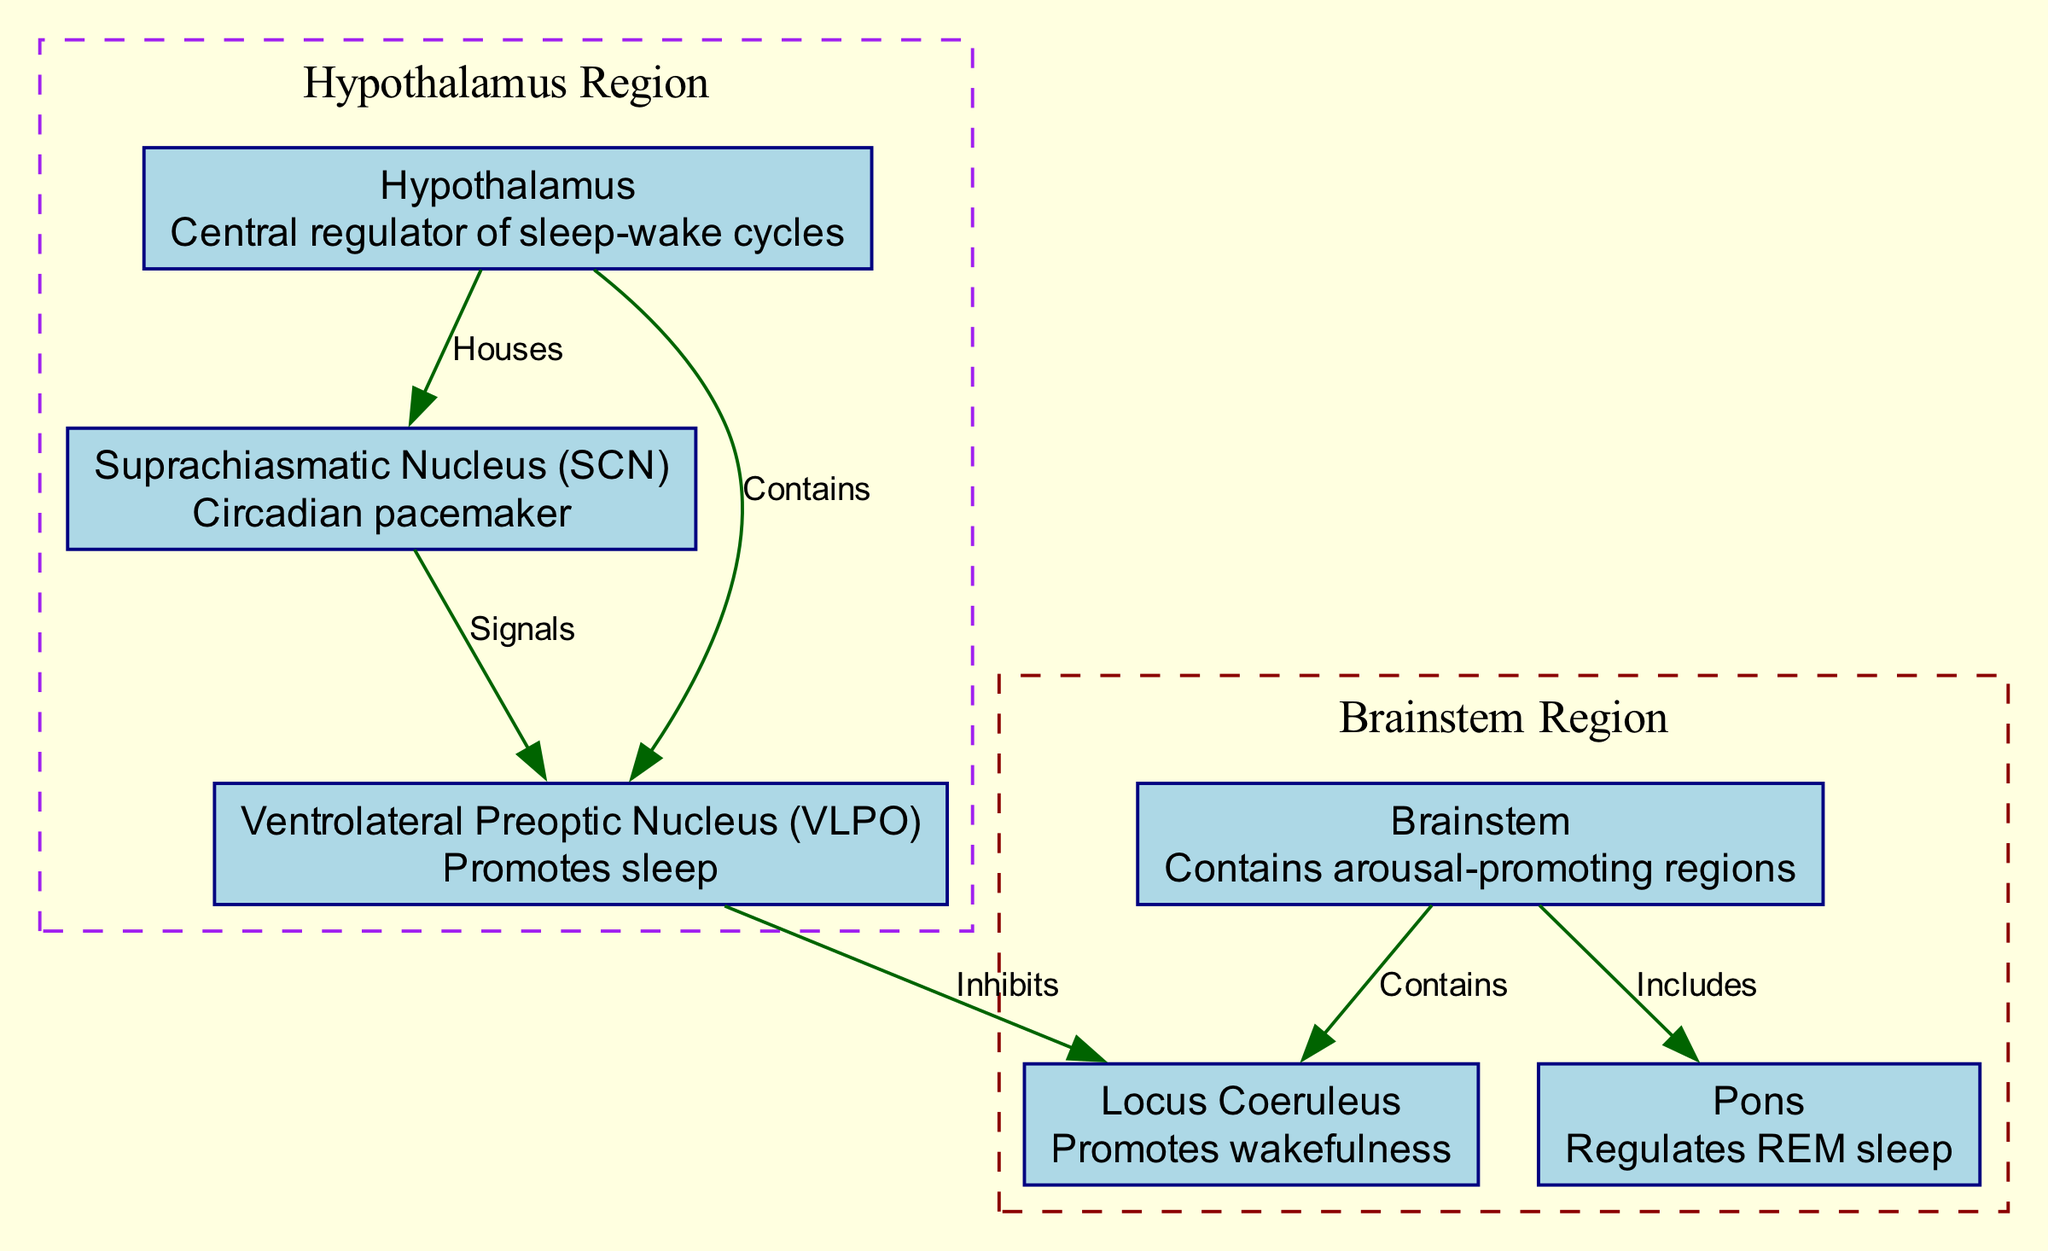What region of the brain is the central regulator of sleep-wake cycles? The diagram indicates that the "Hypothalamus" is labeled as the "Central regulator of sleep-wake cycles," thus identifying it as the answer.
Answer: Hypothalamus How many nodes are there in the diagram? Counting the nodes listed, we find there are six: hypothalamus, suprchiasmatic nucleus, ventrolateral preoptic nucleus, brainstem, pons, and locus coeruleus.
Answer: 6 Which nucleus promotes sleep? The diagram identifies the "Ventrolateral Preoptic Nucleus (VLPO)" with the description "Promotes sleep," which is key to answering the question.
Answer: Ventrolateral Preoptic Nucleus What structure regulates REM sleep? The "Pons" is specifically mentioned in the diagram as responsible for regulating REM sleep, leading to the answer.
Answer: Pons What does the Suprachiasmatic Nucleus signal? Based on the diagram, it shows an arrow from the Suprachiasmatic Nucleus to the Ventrolateral Preoptic Nucleus, indicating that it "Signals" VLPO.
Answer: Ventrolateral Preoptic Nucleus How does the Ventrolateral Preoptic Nucleus interact with the locus coeruleus? The diagram establishes a relationship where the "VLPO" inhibits the "Locus Coeruleus." This defines their interaction succinctly.
Answer: Inhibits What are the two main populations of neurons represented in the brainstem? The diagram includes two nodes under the brainstem: "Pons" and "Locus Coeruleus," making these the two main populations represented.
Answer: Pons and Locus Coeruleus Which brain region houses the Suprachiasmatic Nucleus? The diagram specifies that the "Hypothalamus" houses the "Suprachiasmatic Nucleus," giving a direct answer to the question.
Answer: Hypothalamus What brain region contains arousal-promoting regions? The "Brainstem" is labeled in the diagram as containing arousal-promoting regions, leading to the concise answer.
Answer: Brainstem 